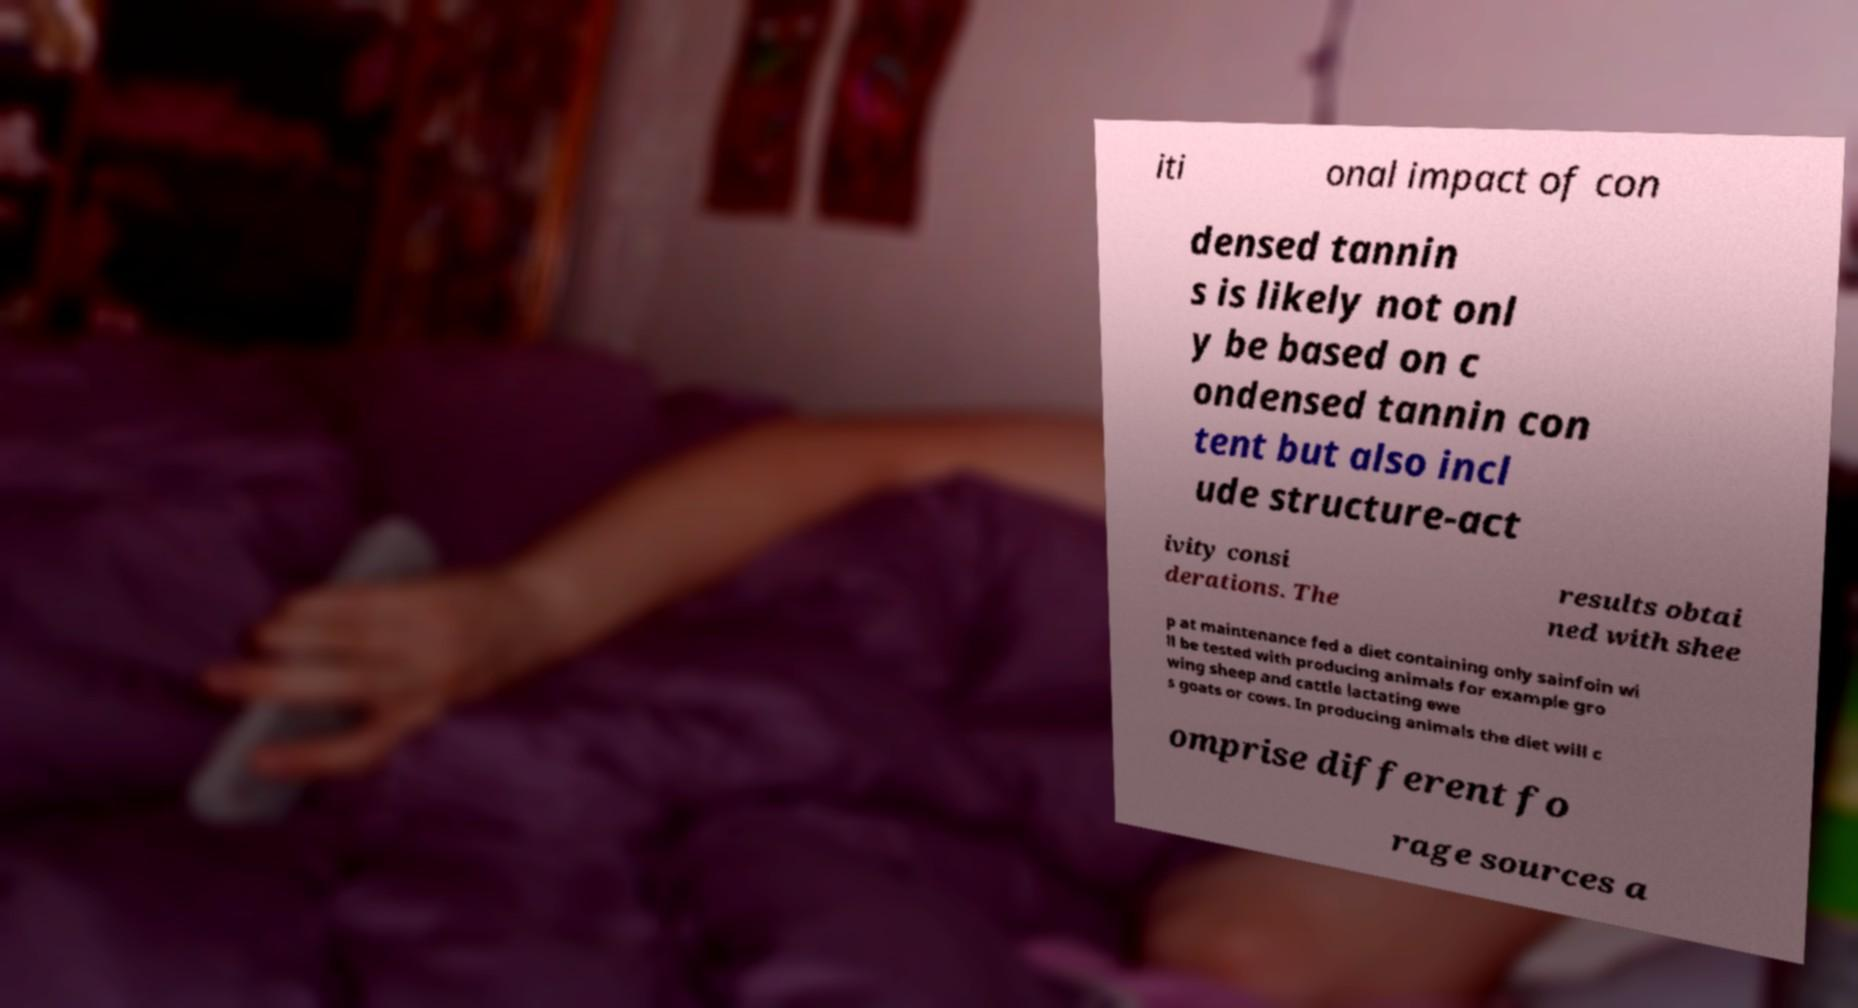Please read and relay the text visible in this image. What does it say? iti onal impact of con densed tannin s is likely not onl y be based on c ondensed tannin con tent but also incl ude structure-act ivity consi derations. The results obtai ned with shee p at maintenance fed a diet containing only sainfoin wi ll be tested with producing animals for example gro wing sheep and cattle lactating ewe s goats or cows. In producing animals the diet will c omprise different fo rage sources a 